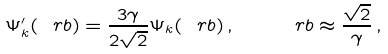<formula> <loc_0><loc_0><loc_500><loc_500>\Psi ^ { \prime } _ { k } ( \ r b ) = \frac { 3 \gamma } { 2 \sqrt { 2 } } \Psi _ { k } ( \ r b ) \, , \quad \ r b \approx \frac { \sqrt { 2 } } { \gamma } \, ,</formula> 